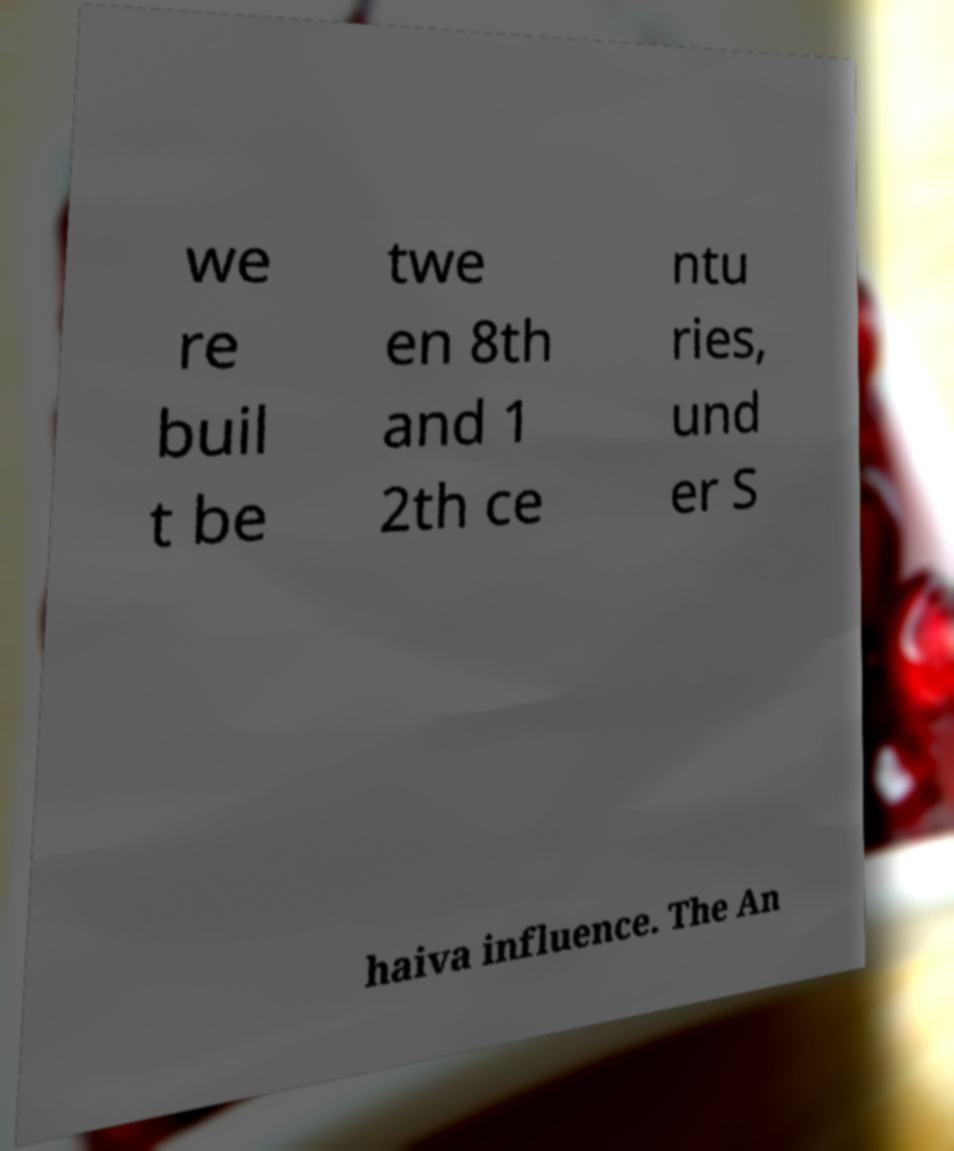Could you assist in decoding the text presented in this image and type it out clearly? we re buil t be twe en 8th and 1 2th ce ntu ries, und er S haiva influence. The An 